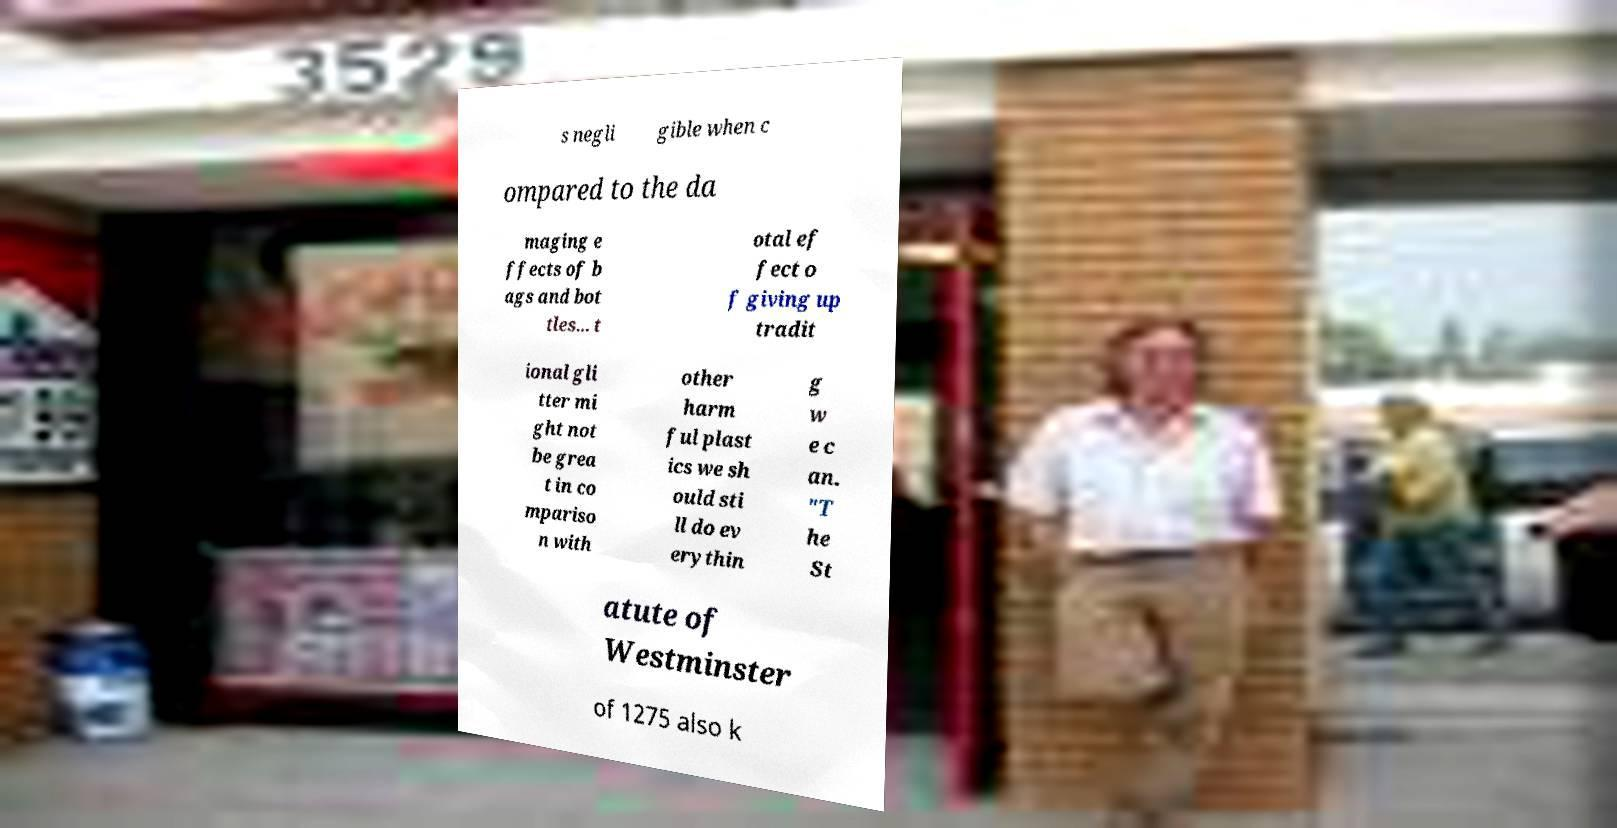I need the written content from this picture converted into text. Can you do that? s negli gible when c ompared to the da maging e ffects of b ags and bot tles... t otal ef fect o f giving up tradit ional gli tter mi ght not be grea t in co mpariso n with other harm ful plast ics we sh ould sti ll do ev erythin g w e c an. "T he St atute of Westminster of 1275 also k 